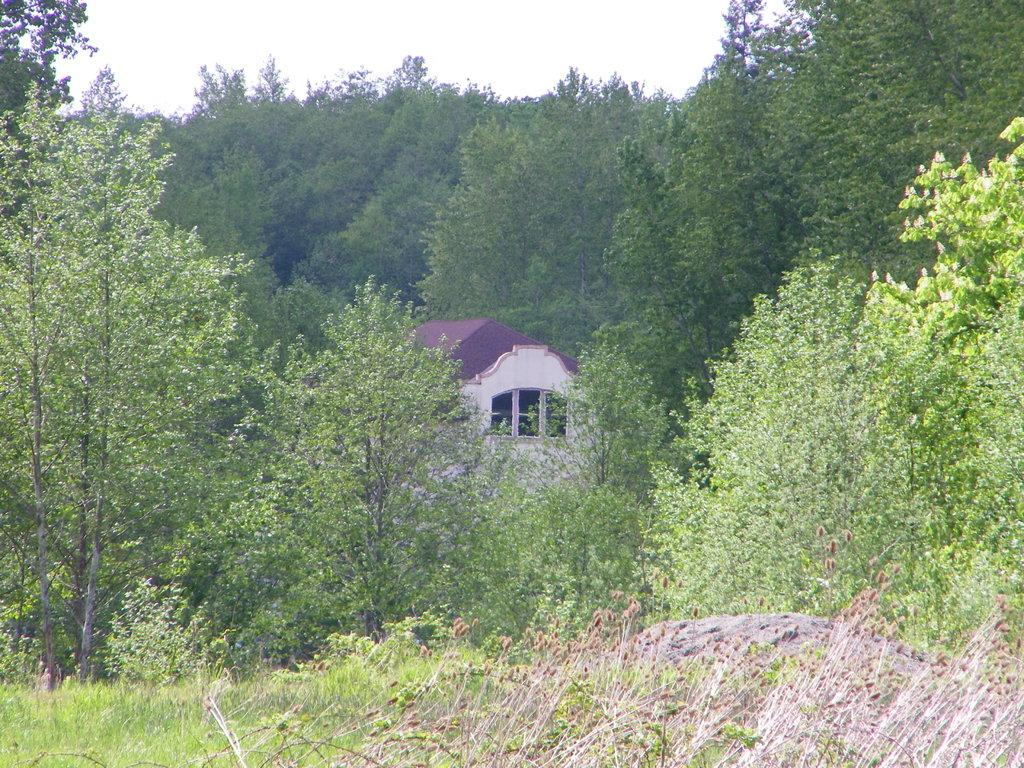What type of vegetation is present in the image? There are many trees, plants, and grass in the image. Can you describe the structure in the middle of the image? There is a house, a wall, and a window in the middle of the image. What is visible at the top of the image? The sky is visible at the top of the image. What type of juice is being served in the image? There is no juice present in the image; it primarily features vegetation, a house, a wall, and a window. Can you hear thunder in the image? There is no sound present in the image, so it is impossible to determine if thunder can be heard. 